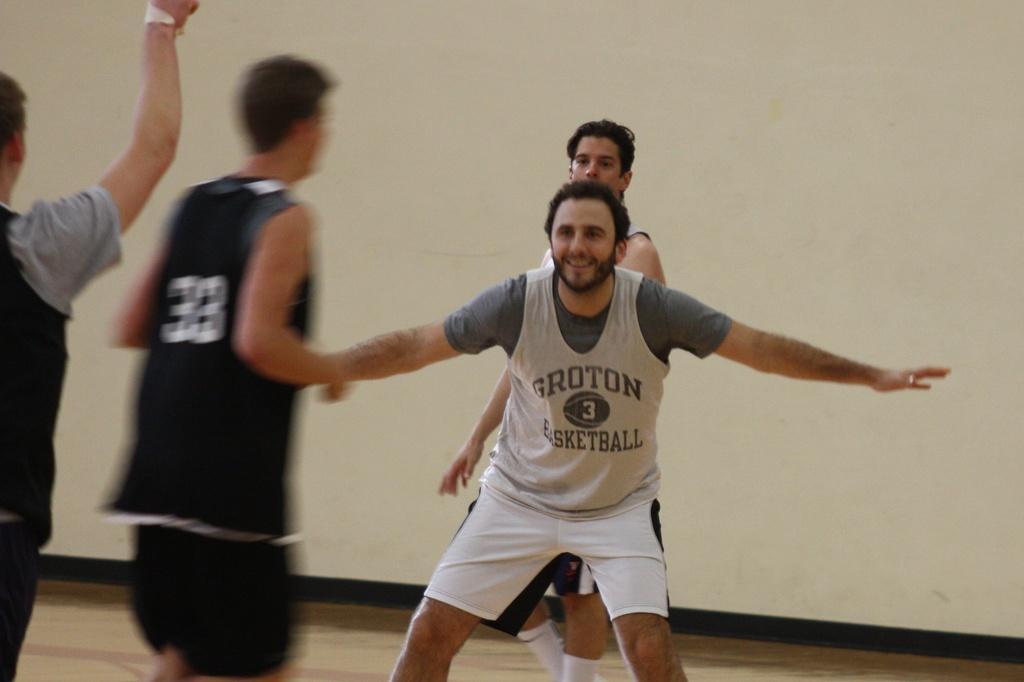How would you summarize this image in a sentence or two? In this image there are few men standing. In the back there is a wall. 